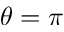<formula> <loc_0><loc_0><loc_500><loc_500>\theta = \pi</formula> 